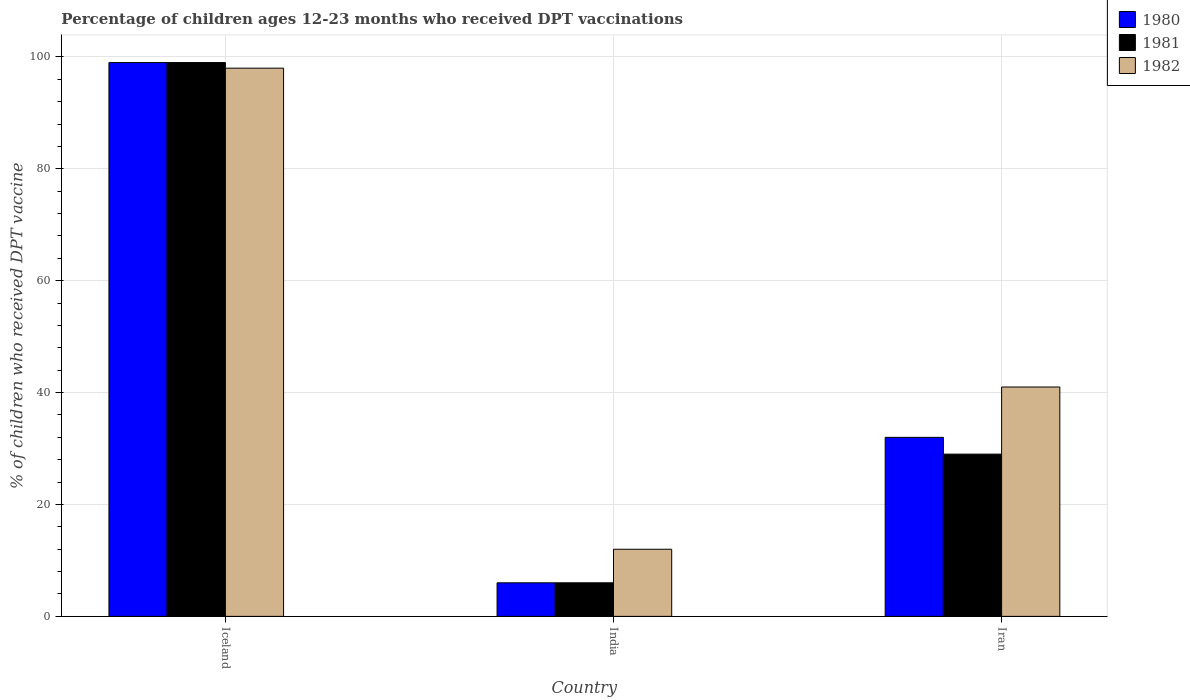Are the number of bars on each tick of the X-axis equal?
Your answer should be very brief. Yes. What is the label of the 3rd group of bars from the left?
Your response must be concise. Iran. In how many cases, is the number of bars for a given country not equal to the number of legend labels?
Ensure brevity in your answer.  0. Across all countries, what is the maximum percentage of children who received DPT vaccination in 1982?
Give a very brief answer. 98. In which country was the percentage of children who received DPT vaccination in 1982 maximum?
Make the answer very short. Iceland. What is the total percentage of children who received DPT vaccination in 1980 in the graph?
Offer a very short reply. 137. What is the average percentage of children who received DPT vaccination in 1982 per country?
Give a very brief answer. 50.33. What is the difference between the percentage of children who received DPT vaccination of/in 1980 and percentage of children who received DPT vaccination of/in 1982 in Iran?
Make the answer very short. -9. What is the ratio of the percentage of children who received DPT vaccination in 1982 in Iceland to that in India?
Provide a succinct answer. 8.17. Is the percentage of children who received DPT vaccination in 1981 in Iceland less than that in India?
Make the answer very short. No. In how many countries, is the percentage of children who received DPT vaccination in 1981 greater than the average percentage of children who received DPT vaccination in 1981 taken over all countries?
Your response must be concise. 1. What does the 3rd bar from the right in Iceland represents?
Offer a terse response. 1980. Is it the case that in every country, the sum of the percentage of children who received DPT vaccination in 1981 and percentage of children who received DPT vaccination in 1982 is greater than the percentage of children who received DPT vaccination in 1980?
Offer a terse response. Yes. How many bars are there?
Provide a succinct answer. 9. Are all the bars in the graph horizontal?
Your response must be concise. No. Are the values on the major ticks of Y-axis written in scientific E-notation?
Keep it short and to the point. No. Does the graph contain any zero values?
Your answer should be very brief. No. Does the graph contain grids?
Your answer should be very brief. Yes. Where does the legend appear in the graph?
Give a very brief answer. Top right. How many legend labels are there?
Make the answer very short. 3. What is the title of the graph?
Make the answer very short. Percentage of children ages 12-23 months who received DPT vaccinations. Does "1987" appear as one of the legend labels in the graph?
Give a very brief answer. No. What is the label or title of the Y-axis?
Offer a very short reply. % of children who received DPT vaccine. What is the % of children who received DPT vaccine of 1980 in Iceland?
Offer a very short reply. 99. What is the % of children who received DPT vaccine of 1982 in India?
Ensure brevity in your answer.  12. What is the % of children who received DPT vaccine of 1980 in Iran?
Give a very brief answer. 32. What is the % of children who received DPT vaccine of 1981 in Iran?
Your response must be concise. 29. What is the % of children who received DPT vaccine in 1982 in Iran?
Offer a terse response. 41. Across all countries, what is the maximum % of children who received DPT vaccine in 1981?
Your answer should be compact. 99. Across all countries, what is the maximum % of children who received DPT vaccine in 1982?
Keep it short and to the point. 98. Across all countries, what is the minimum % of children who received DPT vaccine of 1980?
Provide a succinct answer. 6. Across all countries, what is the minimum % of children who received DPT vaccine of 1981?
Provide a succinct answer. 6. Across all countries, what is the minimum % of children who received DPT vaccine in 1982?
Your answer should be very brief. 12. What is the total % of children who received DPT vaccine in 1980 in the graph?
Provide a short and direct response. 137. What is the total % of children who received DPT vaccine of 1981 in the graph?
Your answer should be compact. 134. What is the total % of children who received DPT vaccine of 1982 in the graph?
Your answer should be very brief. 151. What is the difference between the % of children who received DPT vaccine of 1980 in Iceland and that in India?
Offer a very short reply. 93. What is the difference between the % of children who received DPT vaccine of 1981 in Iceland and that in India?
Your answer should be compact. 93. What is the difference between the % of children who received DPT vaccine in 1982 in Iceland and that in India?
Make the answer very short. 86. What is the difference between the % of children who received DPT vaccine of 1980 in India and that in Iran?
Your answer should be compact. -26. What is the difference between the % of children who received DPT vaccine of 1980 in Iceland and the % of children who received DPT vaccine of 1981 in India?
Provide a succinct answer. 93. What is the difference between the % of children who received DPT vaccine in 1980 in Iceland and the % of children who received DPT vaccine in 1982 in India?
Your answer should be compact. 87. What is the difference between the % of children who received DPT vaccine in 1980 in Iceland and the % of children who received DPT vaccine in 1982 in Iran?
Your response must be concise. 58. What is the difference between the % of children who received DPT vaccine of 1981 in Iceland and the % of children who received DPT vaccine of 1982 in Iran?
Provide a short and direct response. 58. What is the difference between the % of children who received DPT vaccine in 1980 in India and the % of children who received DPT vaccine in 1981 in Iran?
Provide a short and direct response. -23. What is the difference between the % of children who received DPT vaccine in 1980 in India and the % of children who received DPT vaccine in 1982 in Iran?
Give a very brief answer. -35. What is the difference between the % of children who received DPT vaccine in 1981 in India and the % of children who received DPT vaccine in 1982 in Iran?
Provide a short and direct response. -35. What is the average % of children who received DPT vaccine of 1980 per country?
Your answer should be very brief. 45.67. What is the average % of children who received DPT vaccine in 1981 per country?
Provide a short and direct response. 44.67. What is the average % of children who received DPT vaccine of 1982 per country?
Provide a succinct answer. 50.33. What is the difference between the % of children who received DPT vaccine in 1980 and % of children who received DPT vaccine in 1981 in Iceland?
Provide a short and direct response. 0. What is the difference between the % of children who received DPT vaccine in 1980 and % of children who received DPT vaccine in 1981 in India?
Keep it short and to the point. 0. What is the difference between the % of children who received DPT vaccine in 1980 and % of children who received DPT vaccine in 1982 in Iran?
Offer a terse response. -9. What is the difference between the % of children who received DPT vaccine in 1981 and % of children who received DPT vaccine in 1982 in Iran?
Make the answer very short. -12. What is the ratio of the % of children who received DPT vaccine in 1980 in Iceland to that in India?
Provide a succinct answer. 16.5. What is the ratio of the % of children who received DPT vaccine in 1981 in Iceland to that in India?
Provide a short and direct response. 16.5. What is the ratio of the % of children who received DPT vaccine of 1982 in Iceland to that in India?
Your answer should be very brief. 8.17. What is the ratio of the % of children who received DPT vaccine in 1980 in Iceland to that in Iran?
Make the answer very short. 3.09. What is the ratio of the % of children who received DPT vaccine in 1981 in Iceland to that in Iran?
Your answer should be very brief. 3.41. What is the ratio of the % of children who received DPT vaccine of 1982 in Iceland to that in Iran?
Provide a short and direct response. 2.39. What is the ratio of the % of children who received DPT vaccine of 1980 in India to that in Iran?
Offer a very short reply. 0.19. What is the ratio of the % of children who received DPT vaccine of 1981 in India to that in Iran?
Give a very brief answer. 0.21. What is the ratio of the % of children who received DPT vaccine of 1982 in India to that in Iran?
Give a very brief answer. 0.29. What is the difference between the highest and the second highest % of children who received DPT vaccine of 1981?
Offer a terse response. 70. What is the difference between the highest and the lowest % of children who received DPT vaccine of 1980?
Your response must be concise. 93. What is the difference between the highest and the lowest % of children who received DPT vaccine in 1981?
Your answer should be compact. 93. 